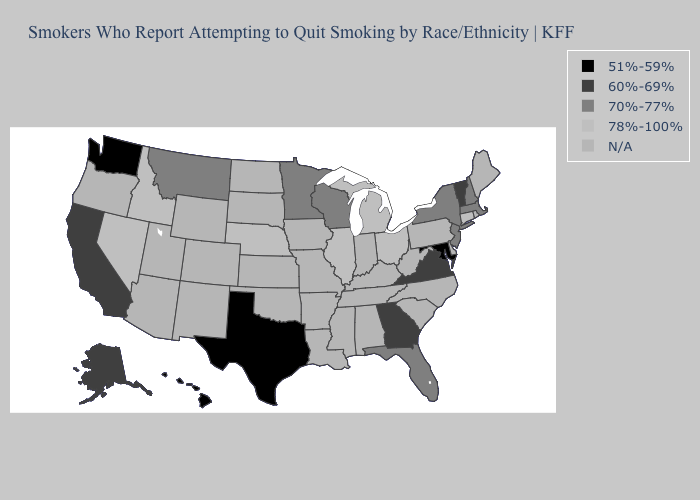What is the lowest value in states that border Iowa?
Give a very brief answer. 70%-77%. What is the value of Rhode Island?
Answer briefly. N/A. Does the first symbol in the legend represent the smallest category?
Write a very short answer. Yes. Which states have the highest value in the USA?
Keep it brief. Connecticut, Idaho, Illinois, Michigan, Nebraska, Nevada, Ohio. Name the states that have a value in the range 51%-59%?
Write a very short answer. Hawaii, Maryland, Texas, Washington. Does Connecticut have the highest value in the Northeast?
Quick response, please. Yes. Name the states that have a value in the range N/A?
Quick response, please. Alabama, Arizona, Arkansas, Colorado, Delaware, Indiana, Iowa, Kansas, Kentucky, Louisiana, Maine, Mississippi, Missouri, New Mexico, North Carolina, North Dakota, Oklahoma, Oregon, Pennsylvania, Rhode Island, South Carolina, South Dakota, Tennessee, Utah, West Virginia, Wyoming. Name the states that have a value in the range 70%-77%?
Give a very brief answer. Florida, Massachusetts, Minnesota, Montana, New Hampshire, New Jersey, New York, Wisconsin. Among the states that border Wyoming , does Montana have the lowest value?
Give a very brief answer. Yes. What is the highest value in the USA?
Answer briefly. 78%-100%. Name the states that have a value in the range 60%-69%?
Quick response, please. Alaska, California, Georgia, Vermont, Virginia. Which states have the lowest value in the USA?
Short answer required. Hawaii, Maryland, Texas, Washington. Among the states that border Delaware , does New Jersey have the highest value?
Give a very brief answer. Yes. 